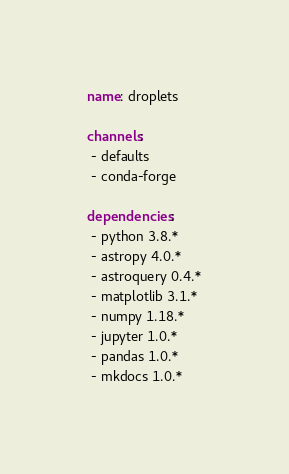Convert code to text. <code><loc_0><loc_0><loc_500><loc_500><_YAML_>name: droplets

channels:
 - defaults
 - conda-forge

dependencies:
 - python 3.8.*
 - astropy 4.0.*
 - astroquery 0.4.*
 - matplotlib 3.1.*
 - numpy 1.18.*
 - jupyter 1.0.*
 - pandas 1.0.*
 - mkdocs 1.0.*
</code> 